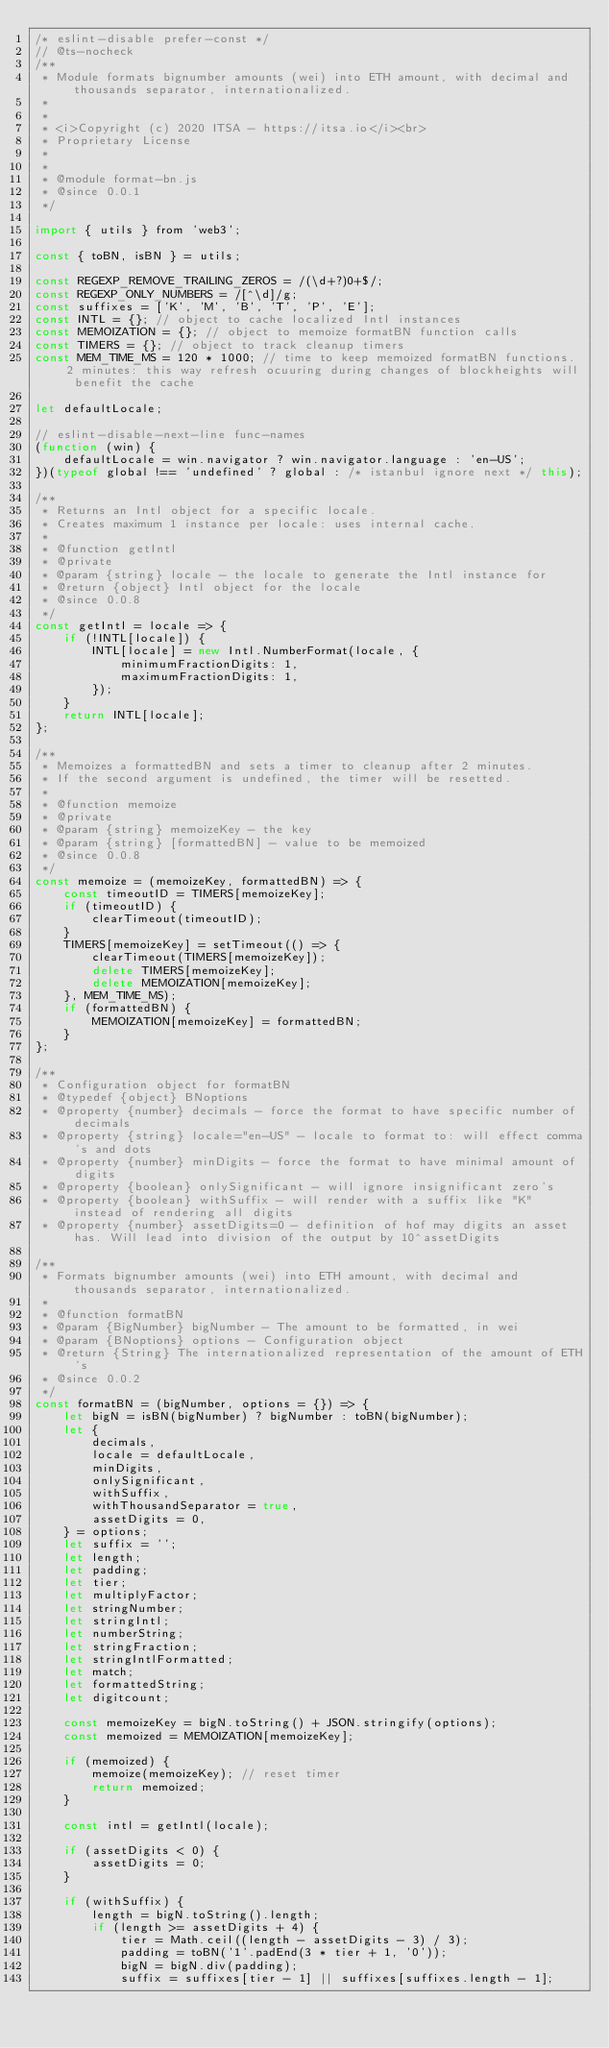<code> <loc_0><loc_0><loc_500><loc_500><_JavaScript_>/* eslint-disable prefer-const */
// @ts-nocheck
/**
 * Module formats bignumber amounts (wei) into ETH amount, with decimal and thousands separator, internationalized.
 *
 *
 * <i>Copyright (c) 2020 ITSA - https://itsa.io</i><br>
 * Proprietary License
 *
 *
 * @module format-bn.js
 * @since 0.0.1
 */

import { utils } from 'web3';

const { toBN, isBN } = utils;

const REGEXP_REMOVE_TRAILING_ZEROS = /(\d+?)0+$/;
const REGEXP_ONLY_NUMBERS = /[^\d]/g;
const suffixes = ['K', 'M', 'B', 'T', 'P', 'E'];
const INTL = {}; // object to cache localized Intl instances
const MEMOIZATION = {}; // object to memoize formatBN function calls
const TIMERS = {}; // object to track cleanup timers
const MEM_TIME_MS = 120 * 1000; // time to keep memoized formatBN functions. 2 minutes: this way refresh ocuuring during changes of blockheights will benefit the cache

let defaultLocale;

// eslint-disable-next-line func-names
(function (win) {
	defaultLocale = win.navigator ? win.navigator.language : 'en-US';
})(typeof global !== 'undefined' ? global : /* istanbul ignore next */ this);

/**
 * Returns an Intl object for a specific locale.
 * Creates maximum 1 instance per locale: uses internal cache.
 *
 * @function getIntl
 * @private
 * @param {string} locale - the locale to generate the Intl instance for
 * @return {object} Intl object for the locale
 * @since 0.0.8
 */
const getIntl = locale => {
	if (!INTL[locale]) {
		INTL[locale] = new Intl.NumberFormat(locale, {
			minimumFractionDigits: 1,
			maximumFractionDigits: 1,
		});
	}
	return INTL[locale];
};

/**
 * Memoizes a formattedBN and sets a timer to cleanup after 2 minutes.
 * If the second argument is undefined, the timer will be resetted.
 *
 * @function memoize
 * @private
 * @param {string} memoizeKey - the key
 * @param {string} [formattedBN] - value to be memoized
 * @since 0.0.8
 */
const memoize = (memoizeKey, formattedBN) => {
	const timeoutID = TIMERS[memoizeKey];
	if (timeoutID) {
		clearTimeout(timeoutID);
	}
	TIMERS[memoizeKey] = setTimeout(() => {
		clearTimeout(TIMERS[memoizeKey]);
		delete TIMERS[memoizeKey];
		delete MEMOIZATION[memoizeKey];
	}, MEM_TIME_MS);
	if (formattedBN) {
		MEMOIZATION[memoizeKey] = formattedBN;
	}
};

/**
 * Configuration object for formatBN
 * @typedef {object} BNoptions
 * @property {number} decimals - force the format to have specific number of decimals
 * @property {string} locale="en-US" - locale to format to: will effect comma's and dots
 * @property {number} minDigits - force the format to have minimal amount of digits
 * @property {boolean} onlySignificant - will ignore insignificant zero's
 * @property {boolean} withSuffix - will render with a suffix like "K" instead of rendering all digits
 * @property {number} assetDigits=0 - definition of hof may digits an asset has. Will lead into division of the output by 10^assetDigits

/**
 * Formats bignumber amounts (wei) into ETH amount, with decimal and thousands separator, internationalized.
 *
 * @function formatBN
 * @param {BigNumber} bigNumber - The amount to be formatted, in wei
 * @param {BNoptions} options - Configuration object
 * @return {String} The internationalized representation of the amount of ETH's
 * @since 0.0.2
 */
const formatBN = (bigNumber, options = {}) => {
	let bigN = isBN(bigNumber) ? bigNumber : toBN(bigNumber);
	let {
		decimals,
		locale = defaultLocale,
		minDigits,
		onlySignificant,
		withSuffix,
		withThousandSeparator = true,
		assetDigits = 0,
	} = options;
	let suffix = '';
	let length;
	let padding;
	let tier;
	let multiplyFactor;
	let stringNumber;
	let stringIntl;
	let numberString;
	let stringFraction;
	let stringIntlFormatted;
	let match;
	let formattedString;
	let digitcount;

	const memoizeKey = bigN.toString() + JSON.stringify(options);
	const memoized = MEMOIZATION[memoizeKey];

	if (memoized) {
		memoize(memoizeKey); // reset timer
		return memoized;
	}

	const intl = getIntl(locale);

	if (assetDigits < 0) {
		assetDigits = 0;
	}

	if (withSuffix) {
		length = bigN.toString().length;
		if (length >= assetDigits + 4) {
			tier = Math.ceil((length - assetDigits - 3) / 3);
			padding = toBN('1'.padEnd(3 * tier + 1, '0'));
			bigN = bigN.div(padding);
			suffix = suffixes[tier - 1] || suffixes[suffixes.length - 1];</code> 